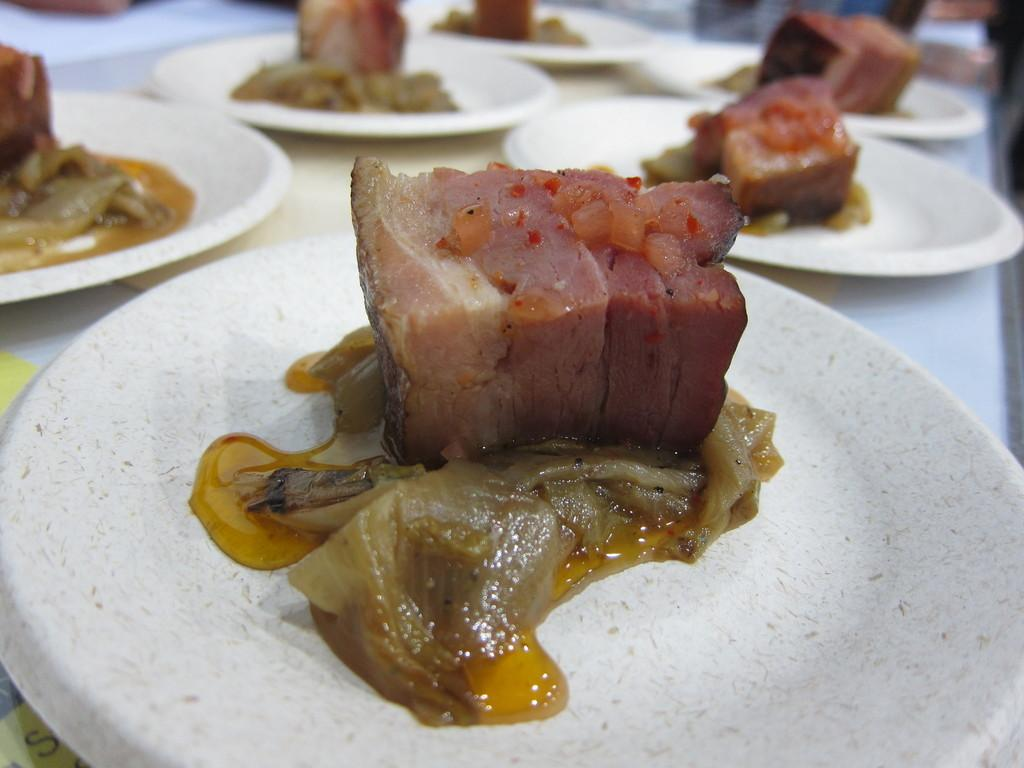What is present on the table in the image? There are food items on plates in the image. Where are the plates located? The plates are on a table. Can you describe the background of the image? The background of the image is blurred. What type of shade is present in the image? There is no shade present in the image. 